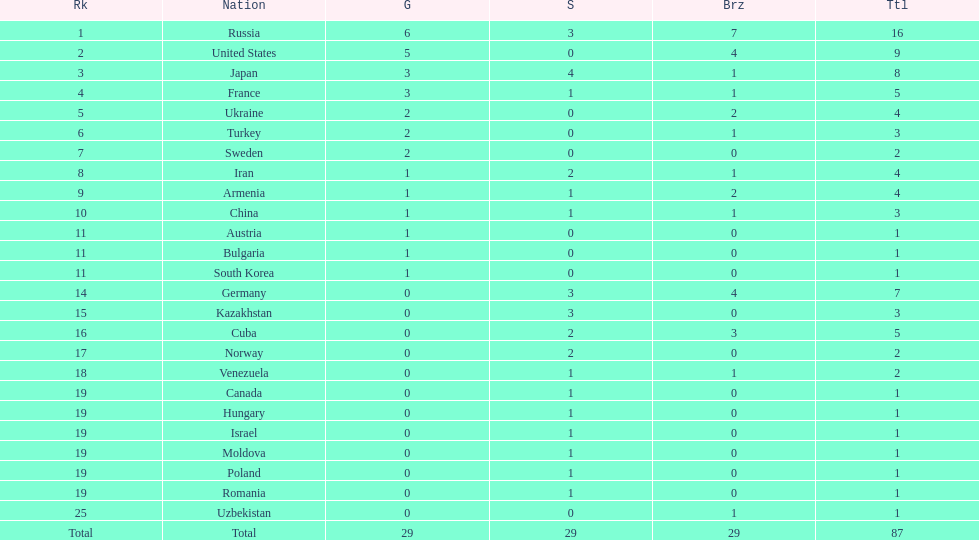What is the number of gold medals won by both japan and france? 3. 